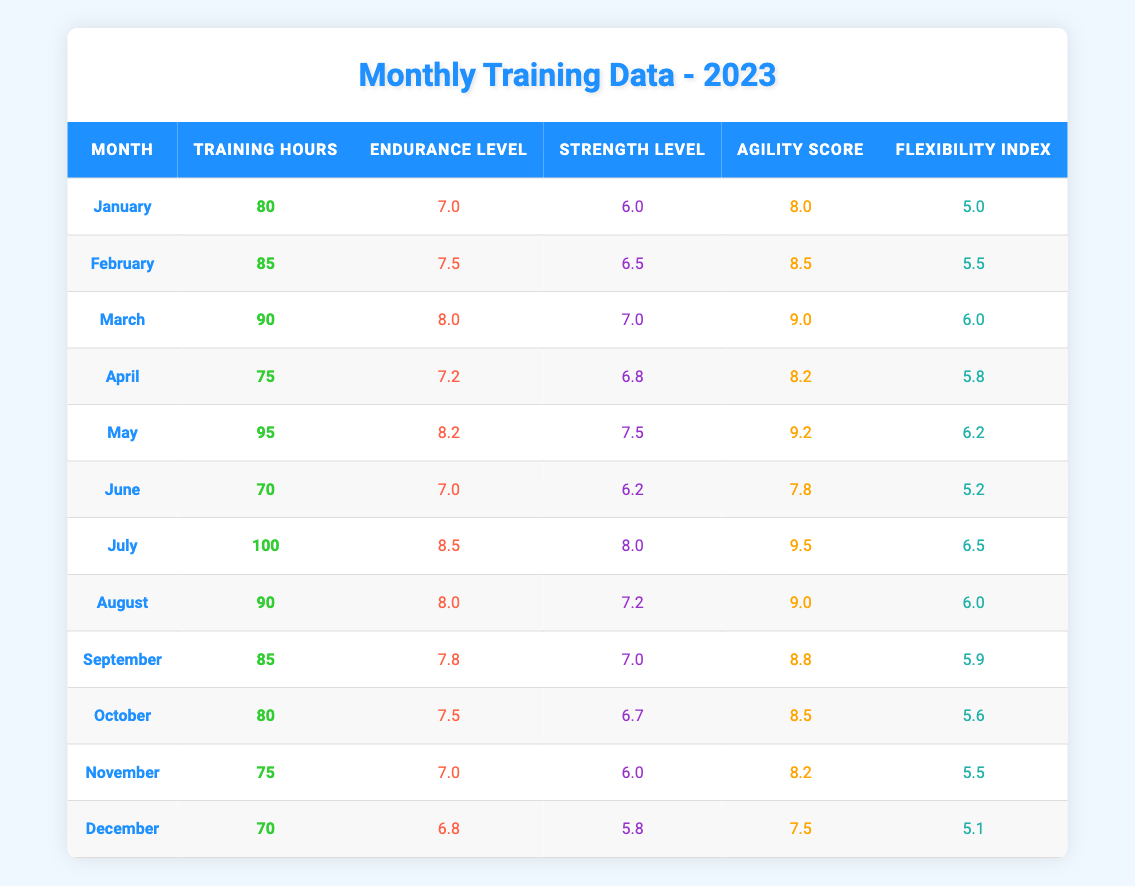What is the highest Agility Score recorded in 2023? The highest Agility Score listed in the table is 9.5, which occurs in July.
Answer: 9.5 Which month had the most Training Hours, and how many hours were recorded? The month with the most Training Hours is July, with a total of 100 hours.
Answer: July, 100 What is the average Endurance Level for the months of June, July, and August? The Endurance Levels for June, July, and August are 7.0, 8.5, and 8.0 respectively. To find the average, we sum these values (7.0 + 8.5 + 8.0 = 23.5) and divide by 3, resulting in an average of 23.5 / 3 = 7.83.
Answer: 7.83 Did the Training Hours in November exceed those in March? November has 75 Training Hours, while March has 90 Training Hours. Since 75 is less than 90, the statement is false.
Answer: No What was the change in Strength Level from January to May? The Strength Level in January was 6.0 and in May it was 7.5. The change is calculated as 7.5 - 6.0 = 1.5.
Answer: 1.5 Which month had a Flexibility Index greater than 6, but less than 6.5? The months with a Flexibility Index greater than 6 and less than 6.5 are May (6.2) and July (6.5). May fits this criterion.
Answer: May What is the total Endurance Level for the year 2023? To find the total Endurance Level, we need to sum the Endurance Levels for each month: 7.0 + 7.5 + 8.0 + 7.2 + 8.2 + 7.0 + 8.5 + 8.0 + 7.8 + 7.5 + 7.0 + 6.8 = 94.7.
Answer: 94.7 Is the Flexibility Index in December lower than in January? The Flexibility Index in December is 5.1 and in January it is 5.0. Since 5.1 is greater than 5.0, this statement is false.
Answer: No How many months had less than 80 Training Hours? A total of 5 months (April, June, November, and December) had less than 80 Training Hours.
Answer: 5 